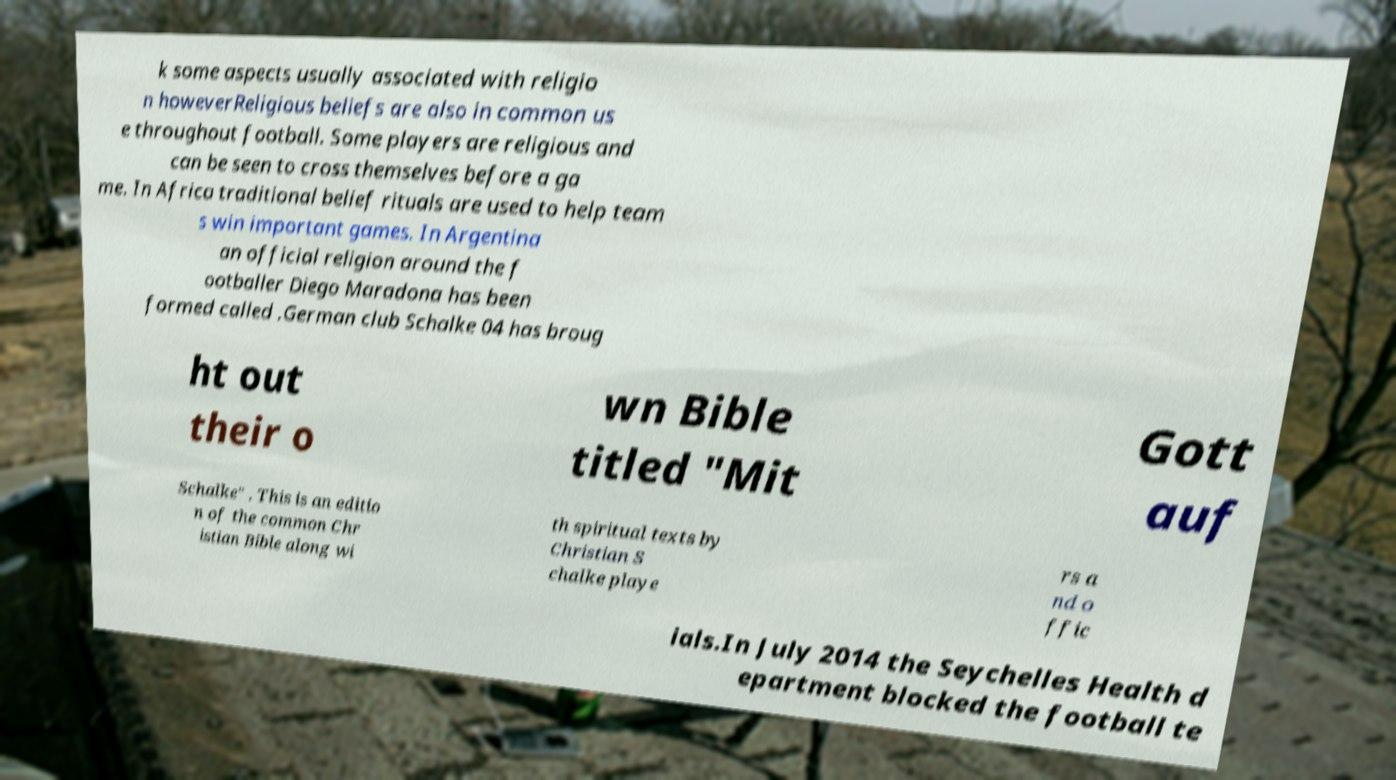What messages or text are displayed in this image? I need them in a readable, typed format. k some aspects usually associated with religio n howeverReligious beliefs are also in common us e throughout football. Some players are religious and can be seen to cross themselves before a ga me. In Africa traditional belief rituals are used to help team s win important games. In Argentina an official religion around the f ootballer Diego Maradona has been formed called .German club Schalke 04 has broug ht out their o wn Bible titled "Mit Gott auf Schalke" . This is an editio n of the common Chr istian Bible along wi th spiritual texts by Christian S chalke playe rs a nd o ffic ials.In July 2014 the Seychelles Health d epartment blocked the football te 